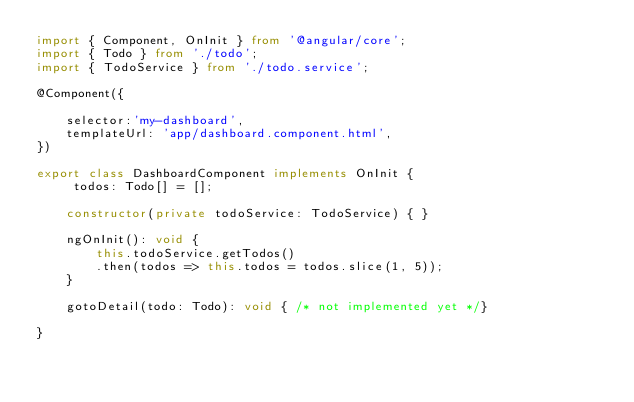<code> <loc_0><loc_0><loc_500><loc_500><_TypeScript_>import { Component, OnInit } from '@angular/core';
import { Todo } from './todo';
import { TodoService } from './todo.service';

@Component({
	
	selector:'my-dashboard',
	templateUrl: 'app/dashboard.component.html',
})

export class DashboardComponent implements OnInit {
	 todos: Todo[] = [];

	constructor(private todoService: TodoService) { }

	ngOnInit(): void {
		this.todoService.getTodos()
		.then(todos => this.todos = todos.slice(1, 5));
	}

	gotoDetail(todo: Todo): void { /* not implemented yet */}

}</code> 